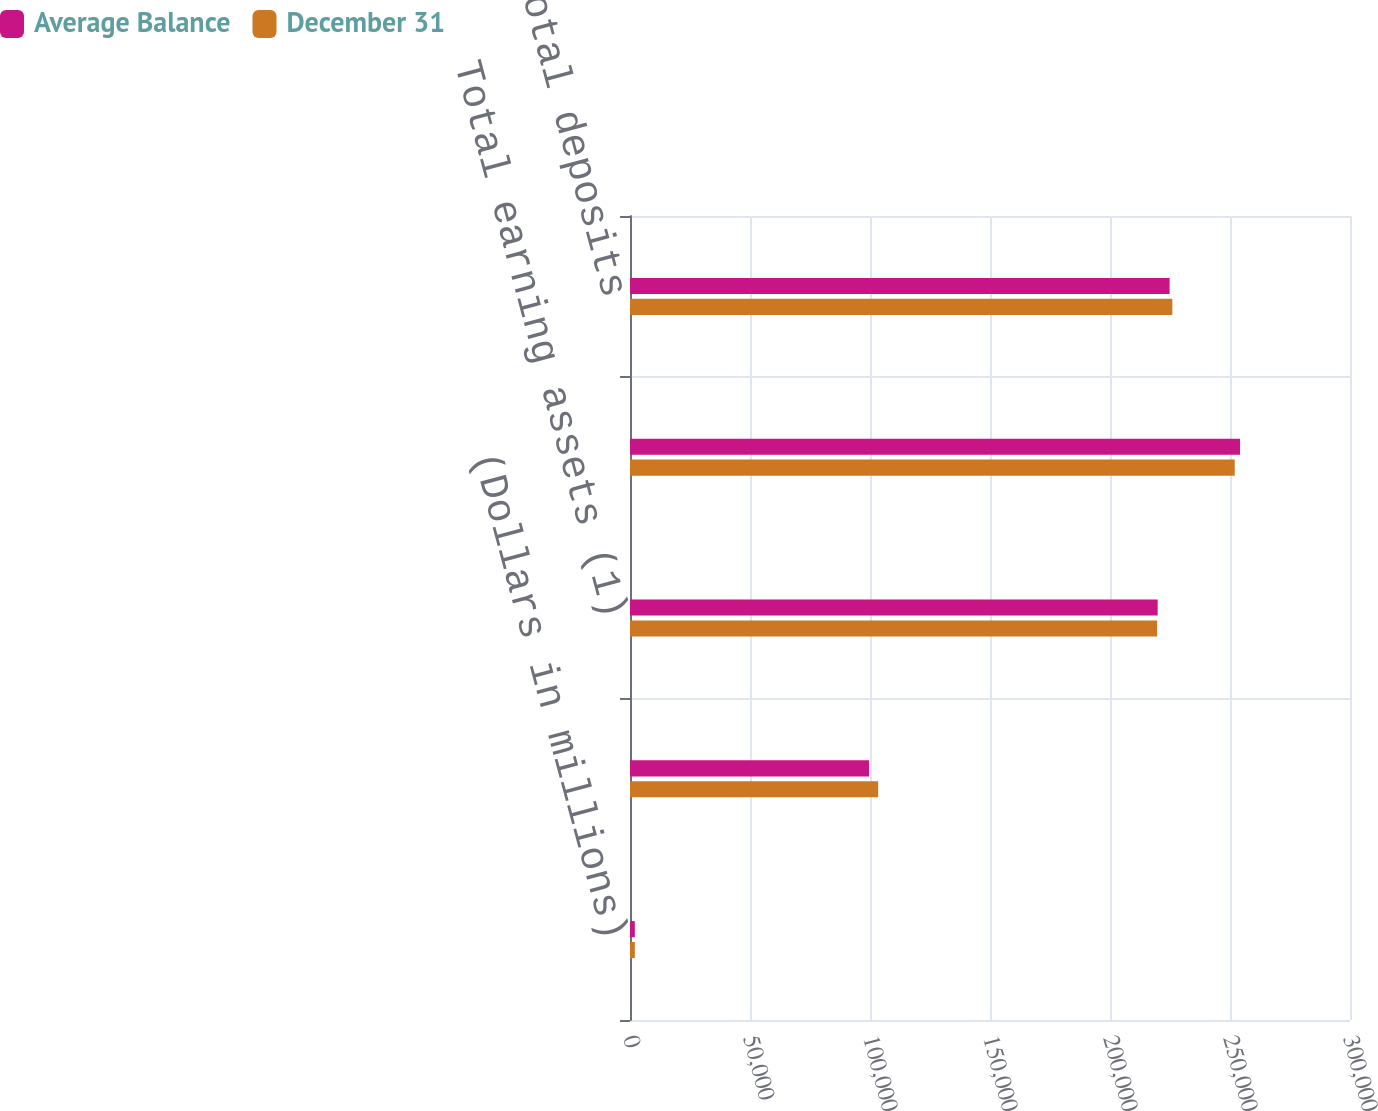<chart> <loc_0><loc_0><loc_500><loc_500><stacked_bar_chart><ecel><fcel>(Dollars in millions)<fcel>Total loans and leases<fcel>Total earning assets (1)<fcel>Total assets (1)<fcel>Total deposits<nl><fcel>Average Balance<fcel>2009<fcel>99596<fcel>219866<fcel>254192<fcel>224840<nl><fcel>December 31<fcel>2009<fcel>103398<fcel>219612<fcel>251969<fcel>225980<nl></chart> 